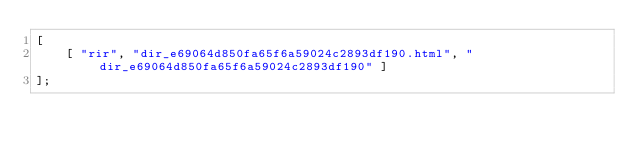<code> <loc_0><loc_0><loc_500><loc_500><_JavaScript_>[
    [ "rir", "dir_e69064d850fa65f6a59024c2893df190.html", "dir_e69064d850fa65f6a59024c2893df190" ]
];</code> 